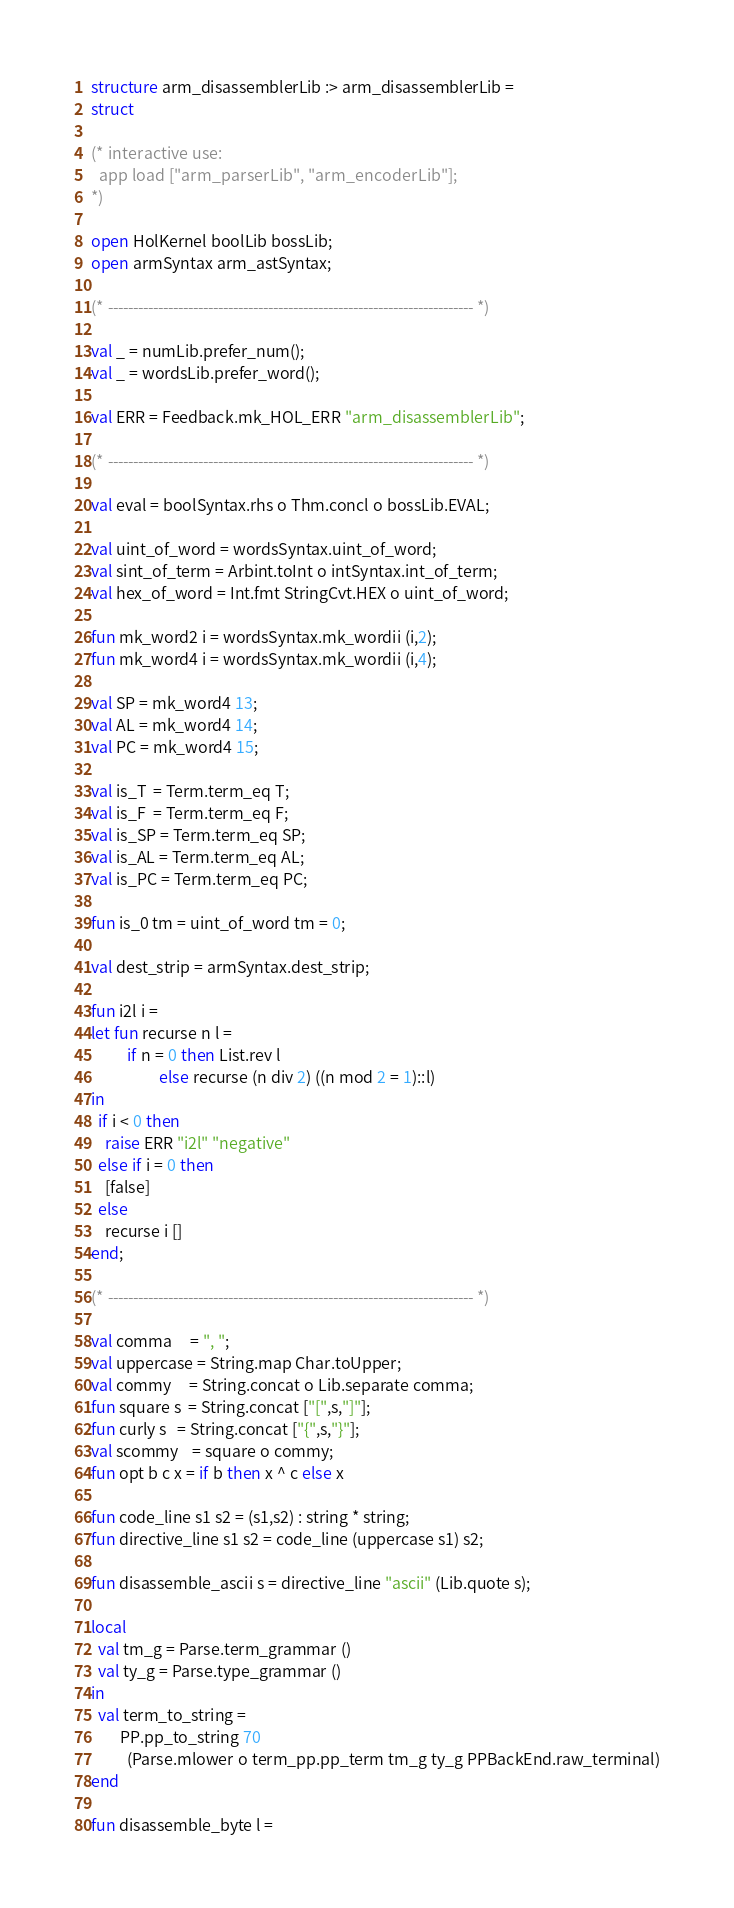Convert code to text. <code><loc_0><loc_0><loc_500><loc_500><_SML_>structure arm_disassemblerLib :> arm_disassemblerLib =
struct

(* interactive use:
  app load ["arm_parserLib", "arm_encoderLib"];
*)

open HolKernel boolLib bossLib;
open armSyntax arm_astSyntax;

(* ------------------------------------------------------------------------- *)

val _ = numLib.prefer_num();
val _ = wordsLib.prefer_word();

val ERR = Feedback.mk_HOL_ERR "arm_disassemblerLib";

(* ------------------------------------------------------------------------- *)

val eval = boolSyntax.rhs o Thm.concl o bossLib.EVAL;

val uint_of_word = wordsSyntax.uint_of_word;
val sint_of_term = Arbint.toInt o intSyntax.int_of_term;
val hex_of_word = Int.fmt StringCvt.HEX o uint_of_word;

fun mk_word2 i = wordsSyntax.mk_wordii (i,2);
fun mk_word4 i = wordsSyntax.mk_wordii (i,4);

val SP = mk_word4 13;
val AL = mk_word4 14;
val PC = mk_word4 15;

val is_T  = Term.term_eq T;
val is_F  = Term.term_eq F;
val is_SP = Term.term_eq SP;
val is_AL = Term.term_eq AL;
val is_PC = Term.term_eq PC;

fun is_0 tm = uint_of_word tm = 0;

val dest_strip = armSyntax.dest_strip;

fun i2l i =
let fun recurse n l =
          if n = 0 then List.rev l
                   else recurse (n div 2) ((n mod 2 = 1)::l)
in
  if i < 0 then
    raise ERR "i2l" "negative"
  else if i = 0 then
    [false]
  else
    recurse i []
end;

(* ------------------------------------------------------------------------- *)

val comma     = ", ";
val uppercase = String.map Char.toUpper;
val commy     = String.concat o Lib.separate comma;
fun square s  = String.concat ["[",s,"]"];
fun curly s   = String.concat ["{",s,"}"];
val scommy    = square o commy;
fun opt b c x = if b then x ^ c else x

fun code_line s1 s2 = (s1,s2) : string * string;
fun directive_line s1 s2 = code_line (uppercase s1) s2;

fun disassemble_ascii s = directive_line "ascii" (Lib.quote s);

local
  val tm_g = Parse.term_grammar ()
  val ty_g = Parse.type_grammar ()
in
  val term_to_string =
        PP.pp_to_string 70
          (Parse.mlower o term_pp.pp_term tm_g ty_g PPBackEnd.raw_terminal)
end

fun disassemble_byte l =</code> 